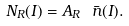Convert formula to latex. <formula><loc_0><loc_0><loc_500><loc_500>N _ { R } ( I ) = A _ { R } \ \bar { n } ( I ) .</formula> 